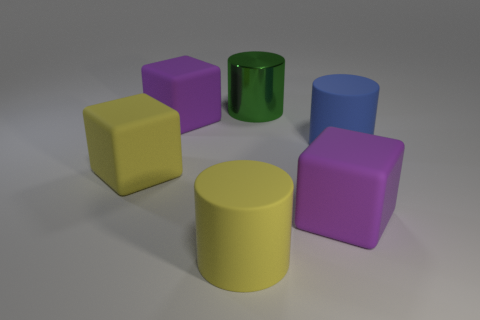Subtract all purple matte cubes. How many cubes are left? 1 Add 1 big yellow metal balls. How many objects exist? 7 Subtract 2 cylinders. How many cylinders are left? 1 Subtract all cyan cylinders. How many yellow blocks are left? 1 Subtract all small blue matte cylinders. Subtract all blue rubber cylinders. How many objects are left? 5 Add 2 large blue matte things. How many large blue matte things are left? 3 Add 5 green things. How many green things exist? 6 Subtract all yellow cubes. How many cubes are left? 2 Subtract 0 brown balls. How many objects are left? 6 Subtract all blue blocks. Subtract all cyan spheres. How many blocks are left? 3 